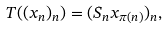Convert formula to latex. <formula><loc_0><loc_0><loc_500><loc_500>T ( ( x _ { n } ) _ { n } ) = ( S _ { n } x _ { \pi ( n ) } ) _ { n } ,</formula> 